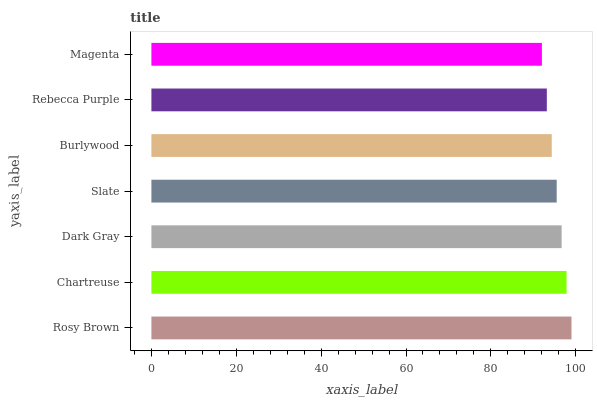Is Magenta the minimum?
Answer yes or no. Yes. Is Rosy Brown the maximum?
Answer yes or no. Yes. Is Chartreuse the minimum?
Answer yes or no. No. Is Chartreuse the maximum?
Answer yes or no. No. Is Rosy Brown greater than Chartreuse?
Answer yes or no. Yes. Is Chartreuse less than Rosy Brown?
Answer yes or no. Yes. Is Chartreuse greater than Rosy Brown?
Answer yes or no. No. Is Rosy Brown less than Chartreuse?
Answer yes or no. No. Is Slate the high median?
Answer yes or no. Yes. Is Slate the low median?
Answer yes or no. Yes. Is Rosy Brown the high median?
Answer yes or no. No. Is Dark Gray the low median?
Answer yes or no. No. 